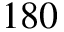Convert formula to latex. <formula><loc_0><loc_0><loc_500><loc_500>1 8 0</formula> 